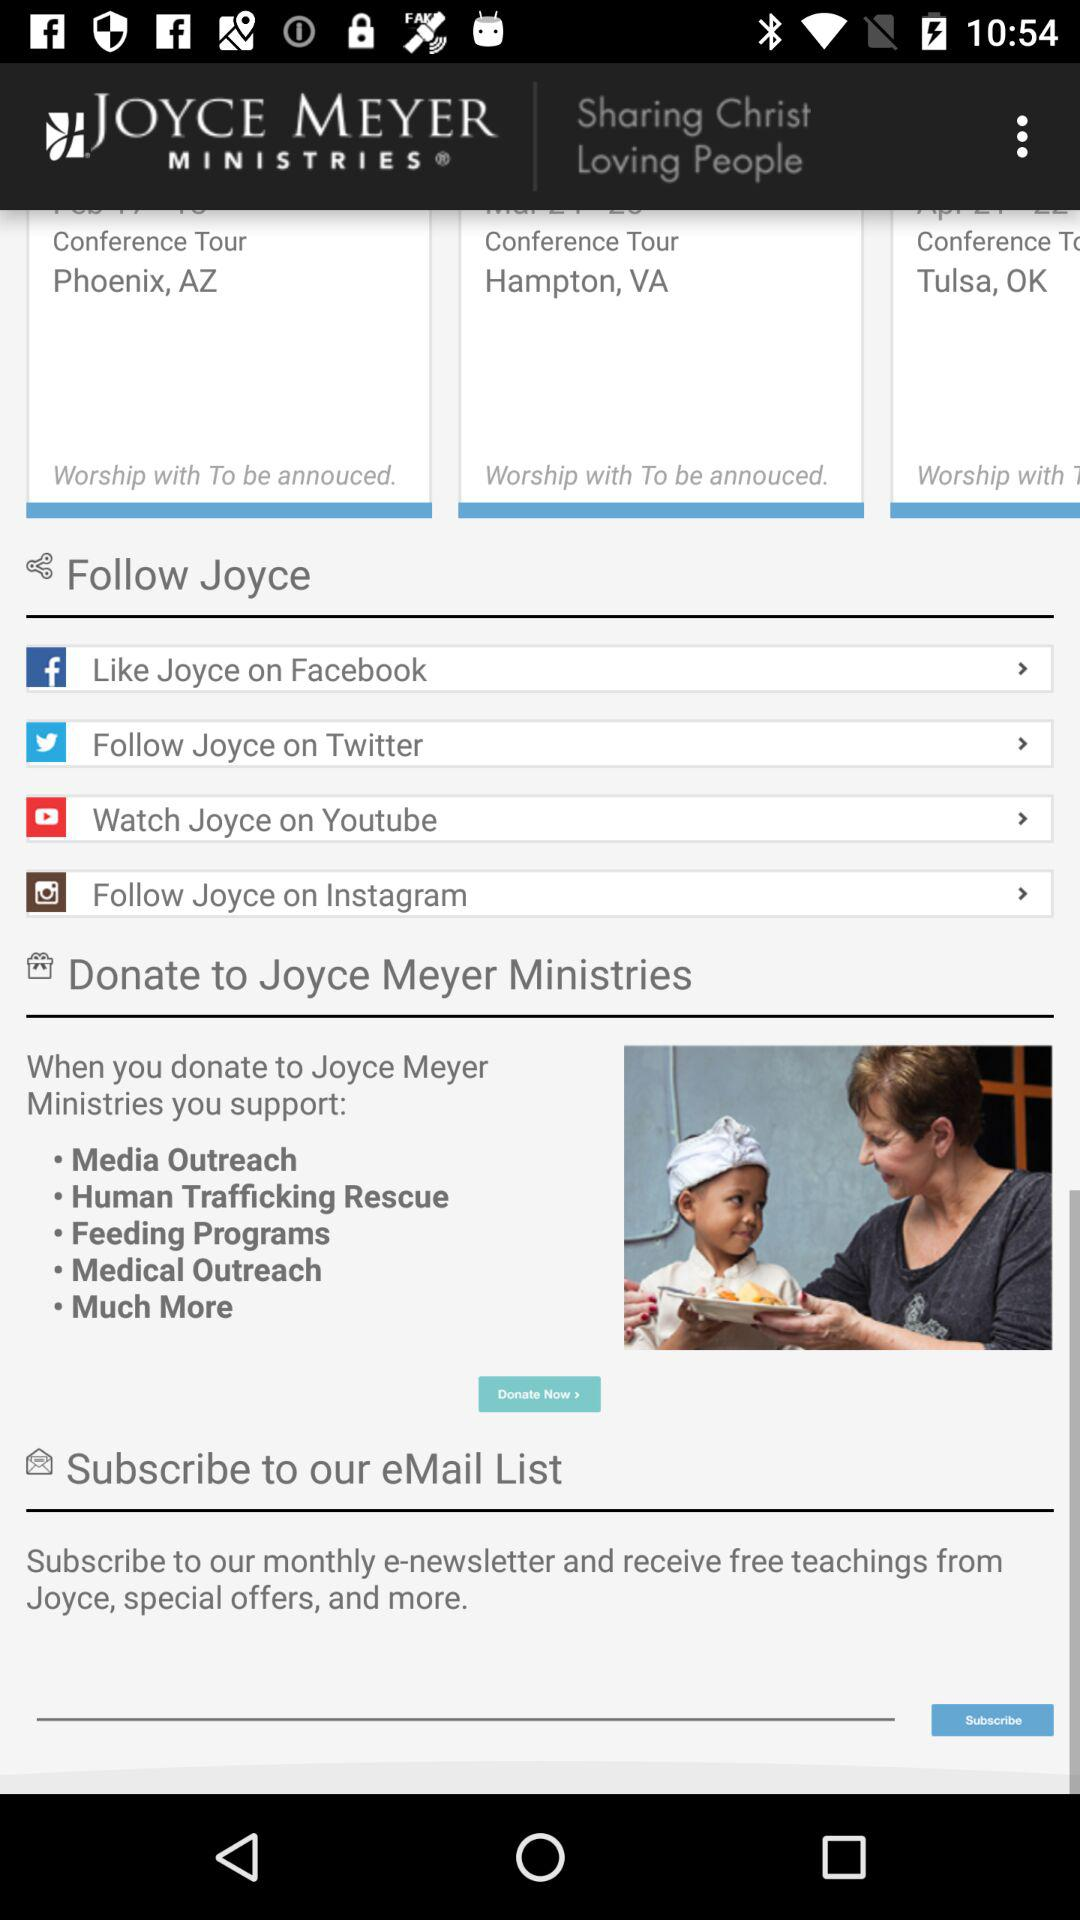How many items are in the donate section?
Answer the question using a single word or phrase. 5 